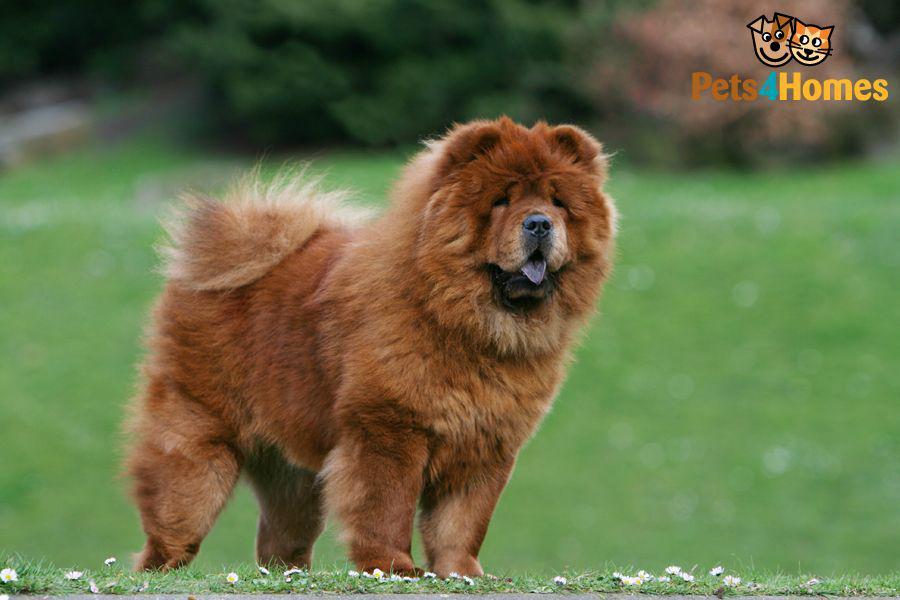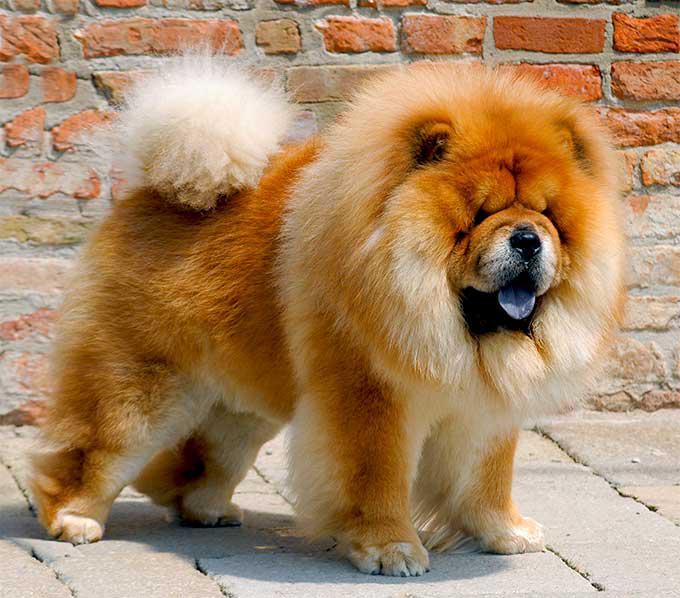The first image is the image on the left, the second image is the image on the right. Evaluate the accuracy of this statement regarding the images: "One of the images only shows the head of a dog.". Is it true? Answer yes or no. No. The first image is the image on the left, the second image is the image on the right. Given the left and right images, does the statement "An image shows a chow standing on a brick-type surface." hold true? Answer yes or no. Yes. 